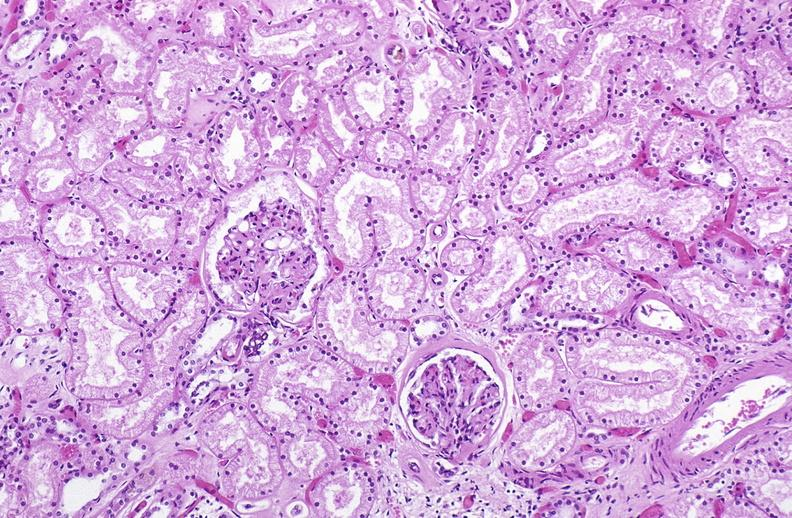what does this image show?
Answer the question using a single word or phrase. Atn acute tubular necrosis 